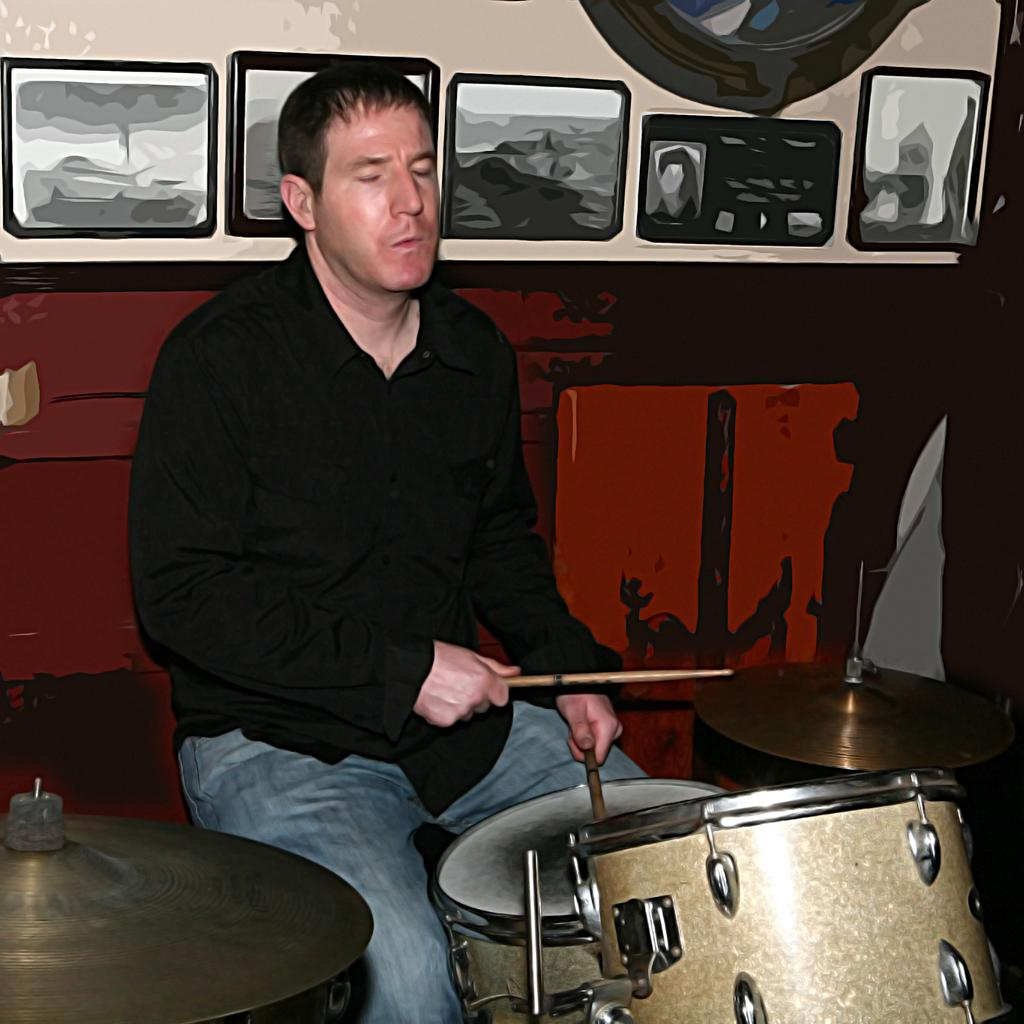What is the man in the image doing? The man is playing the drums. What is the man wearing in the image? The man is wearing a black shirt and jeans. What is the man's position in the image? The man is sitting. What can be seen in the background of the image? There is a wall in the background of the image, and frames are attached to the wall. What is the man's opinion on the rail system in the image? There is no rail system present in the image, and therefore no opportunity to express an opinion about it. 